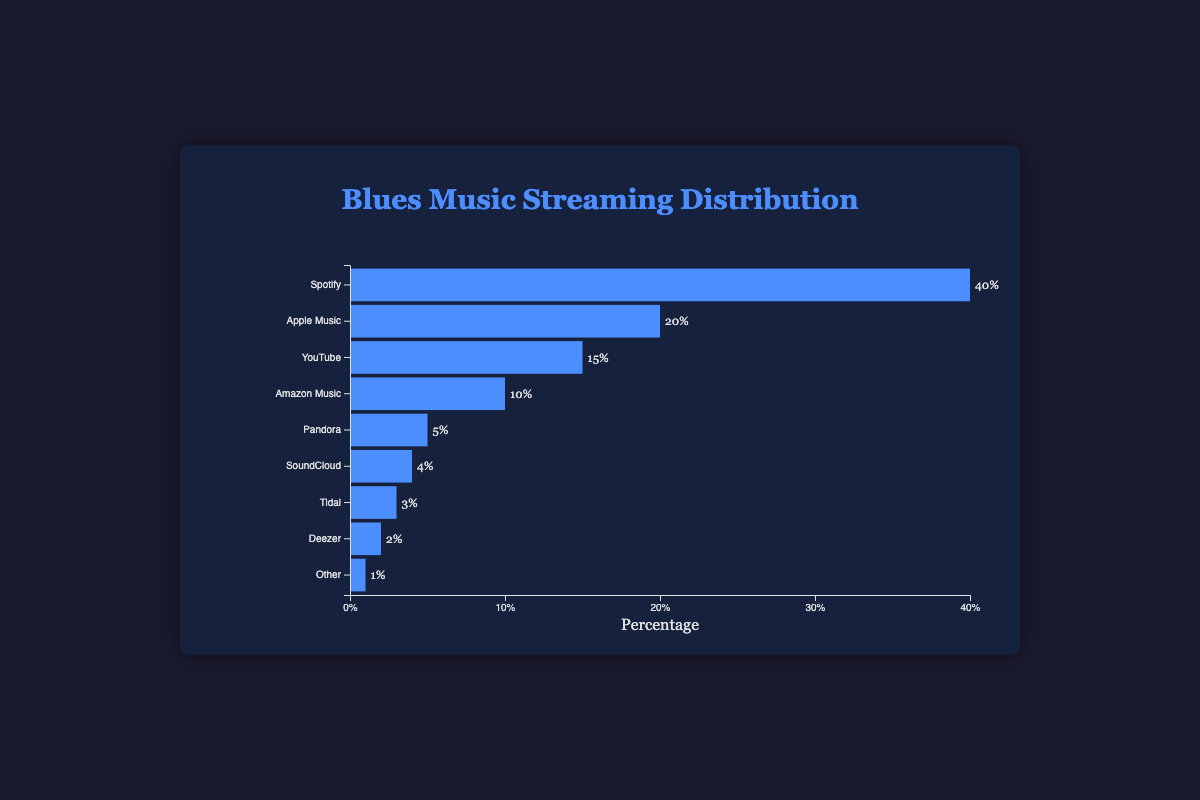Which platform has the highest percentage of blues music streaming? Looking at the lengths of the bars in the chart, the bar labeled "Spotify" is the longest, indicating it has the highest percentage of streaming.
Answer: Spotify Which two platforms together account for 60% of the streaming time? Adding the percentages of Spotify and Apple Music (40% + 20%) equals 60%.
Answer: Spotify and Apple Music How much more streaming time does Spotify have compared to YouTube? The difference in percentages between Spotify (40%) and YouTube (15%) is 25%.
Answer: 25% Which platform has the shortest bar in the chart? Observing the lengths of the bars, the shortest bar belongs to "Other" with 1%.
Answer: Other What is the total percentage of streaming for platforms with less than 10% each? Summing up the percentages for Pandora, SoundCloud, Tidal, Deezer, and Other: (5% + 4% + 3% + 2% + 1%) = 15%.
Answer: 15% What is the combined minutes streamed for Amazon Music and Pandora? Amazon Music has 30000 minutes and Pandora has 15000 minutes. Adding them together gives 45000 minutes.
Answer: 45000 How do the percentages of Apple Music and SoundCloud compare? Apple Music has a percentage of 20%, while SoundCloud has a percentage of 4%. Apple Music's percentage is higher than SoundCloud's.
Answer: Apple Music is higher If Deezer increased its streaming percentage by 3%, how would it compare to Tidal? Deezer's current percentage is 2%. Increasing it by 3% makes it 5%, which equals Tidal's 3% plus 2%.
Answer: Equal to Which platforms have streaming percentages that sum up to 25%? Combining YouTube (15%) and Amazon Music (10%) sums up to 25%.
Answer: YouTube and Amazon Music How many platforms streaming times are represented as single-digit percentages in the chart? Counting the platforms with percentages less than 10%: Pandora (5%), SoundCloud (4%), Tidal (3%), Deezer (2%), and Other (1%). There are 5 platforms.
Answer: 5 platforms 